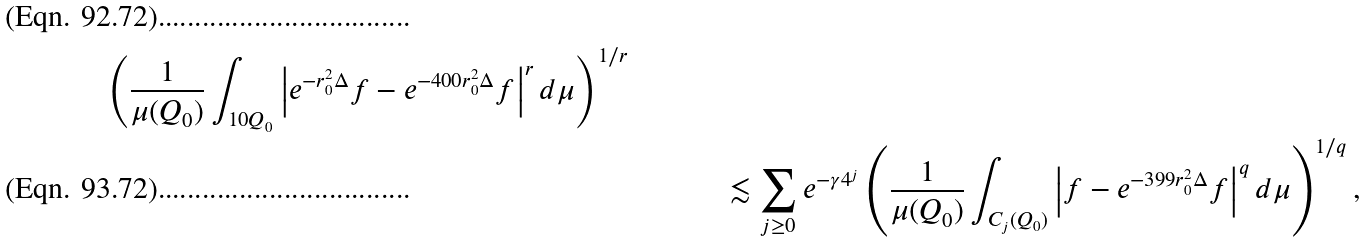Convert formula to latex. <formula><loc_0><loc_0><loc_500><loc_500>{ \left ( \frac { 1 } { \mu ( Q _ { 0 } ) } \int _ { 1 0 Q _ { 0 } } \left | e ^ { - r _ { 0 } ^ { 2 } \Delta } f - e ^ { - 4 0 0 r _ { 0 } ^ { 2 } \Delta } f \right | ^ { r } d \mu \right ) ^ { 1 / r } } & & \\ & & \lesssim \sum _ { j \geq 0 } e ^ { - \gamma 4 ^ { j } } \left ( \frac { 1 } { \mu ( Q _ { 0 } ) } \int _ { C _ { j } ( Q _ { 0 } ) } \left | f - e ^ { - 3 9 9 r _ { 0 } ^ { 2 } \Delta } f \right | ^ { q } d \mu \right ) ^ { 1 / q } ,</formula> 